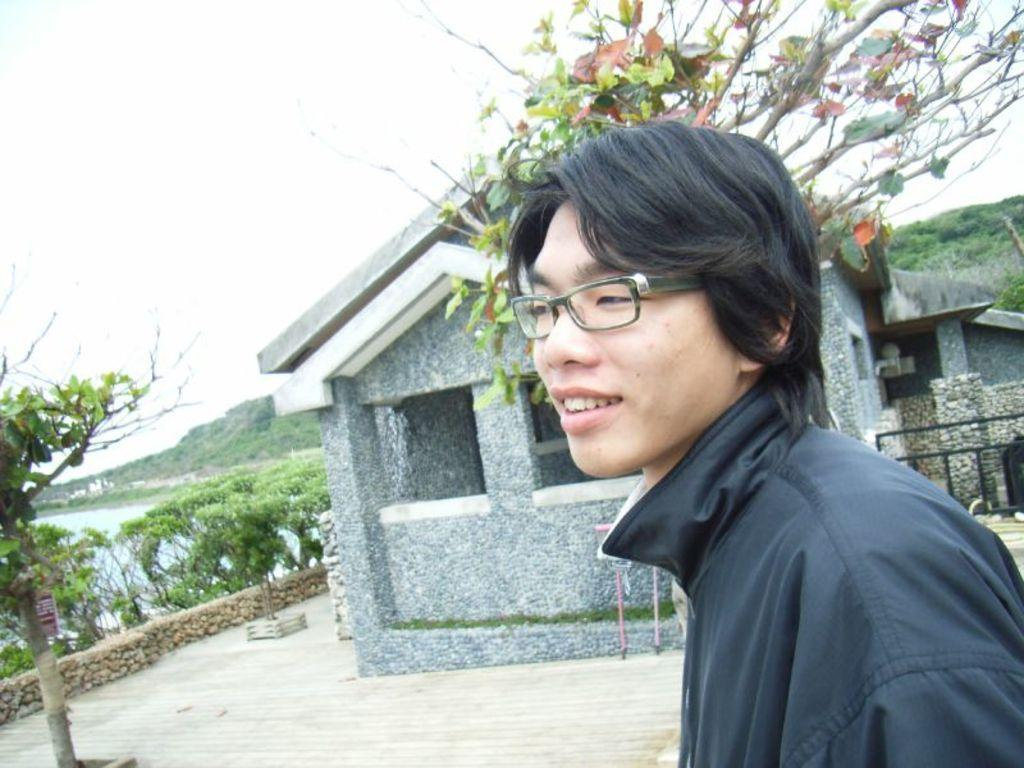Who or what is the main subject in the center of the image? There is a person in the center of the image. What can be seen in the background of the image? There is a building, trees, a hill, and the sky visible in the background of the image. What is the reason for the sink's existence in the image? There is no sink present in the image, so it is not possible to determine the reason for its existence. 